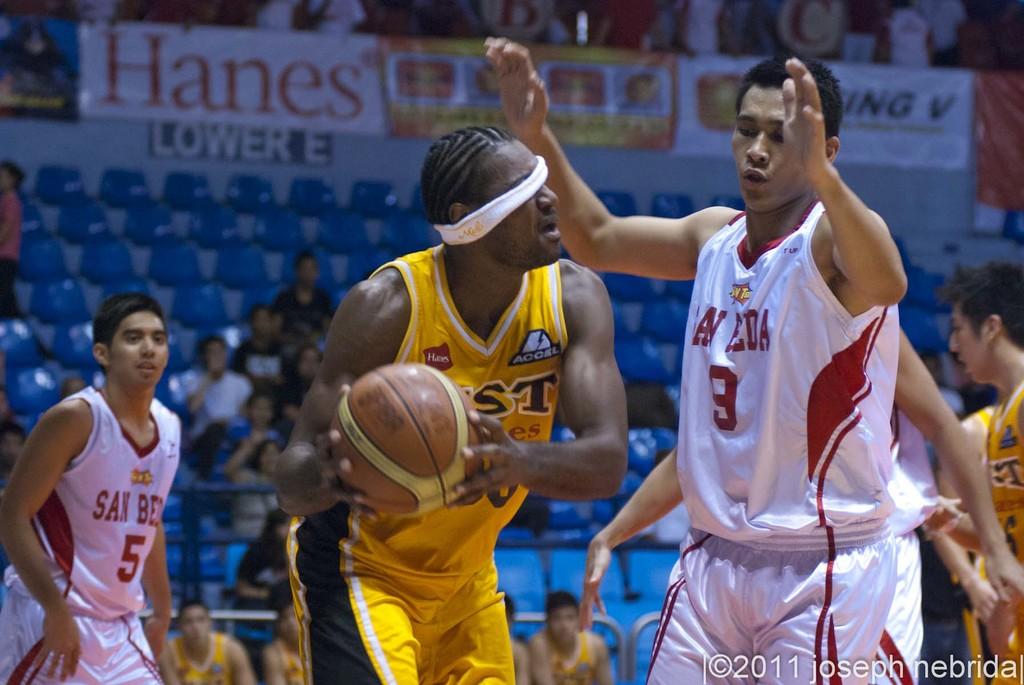What colour is the jersey of the player with the basketball?
Give a very brief answer. Answering does not require reading text in the image. What clothing brand is being advertised above number 5?
Your response must be concise. Hanes. 